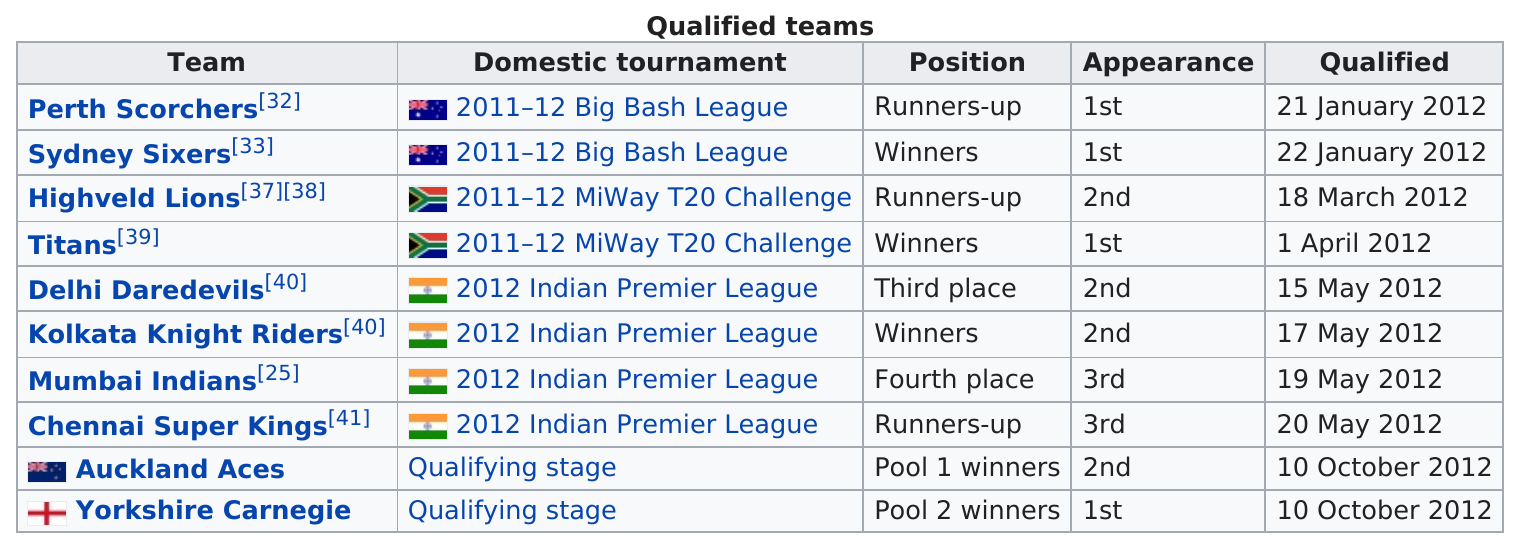List a handful of essential elements in this visual. The Kolkata Knight Riders team emerged as the winner of the 2012 Indian Premier League competition, defeating all other teams to secure the top spot. The Highveld Lions emerged as the runners-up in the MIWAY T20 Challenge after finishing behind the Titans. On January 22, 2012, the Sydney Sixers placed first. The Titans were the winners. Auckland Aces and Yorkshire Carnegie were the most recent teams to qualify for the tournament. 